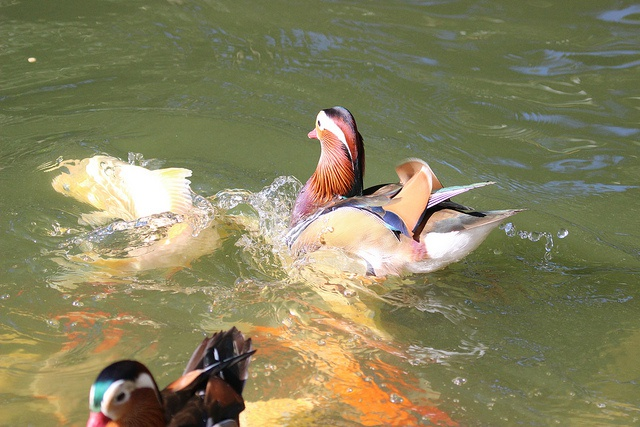Describe the objects in this image and their specific colors. I can see bird in olive, white, tan, lightpink, and darkgray tones, bird in olive, ivory, khaki, and tan tones, and bird in olive, black, maroon, and gray tones in this image. 